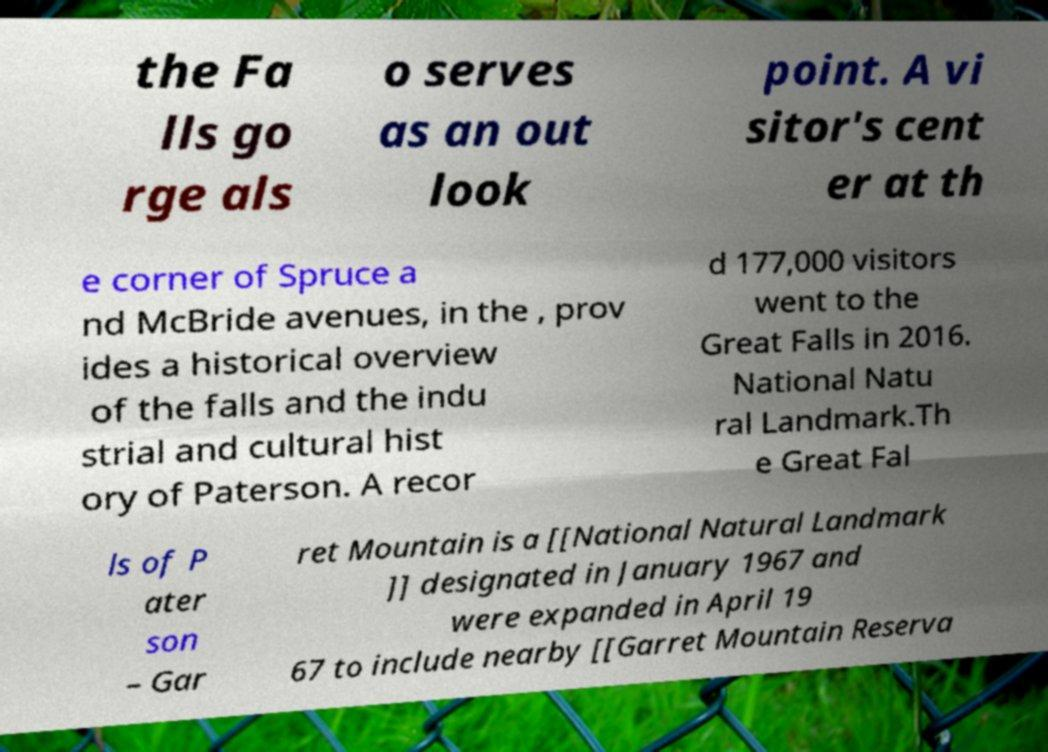Could you extract and type out the text from this image? the Fa lls go rge als o serves as an out look point. A vi sitor's cent er at th e corner of Spruce a nd McBride avenues, in the , prov ides a historical overview of the falls and the indu strial and cultural hist ory of Paterson. A recor d 177,000 visitors went to the Great Falls in 2016. National Natu ral Landmark.Th e Great Fal ls of P ater son – Gar ret Mountain is a [[National Natural Landmark ]] designated in January 1967 and were expanded in April 19 67 to include nearby [[Garret Mountain Reserva 